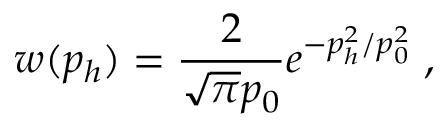<formula> <loc_0><loc_0><loc_500><loc_500>w ( p _ { h } ) = \frac { 2 } { \sqrt { \pi } p _ { 0 } } e ^ { - p _ { h } ^ { 2 } / p _ { 0 } ^ { 2 } } \, ,</formula> 